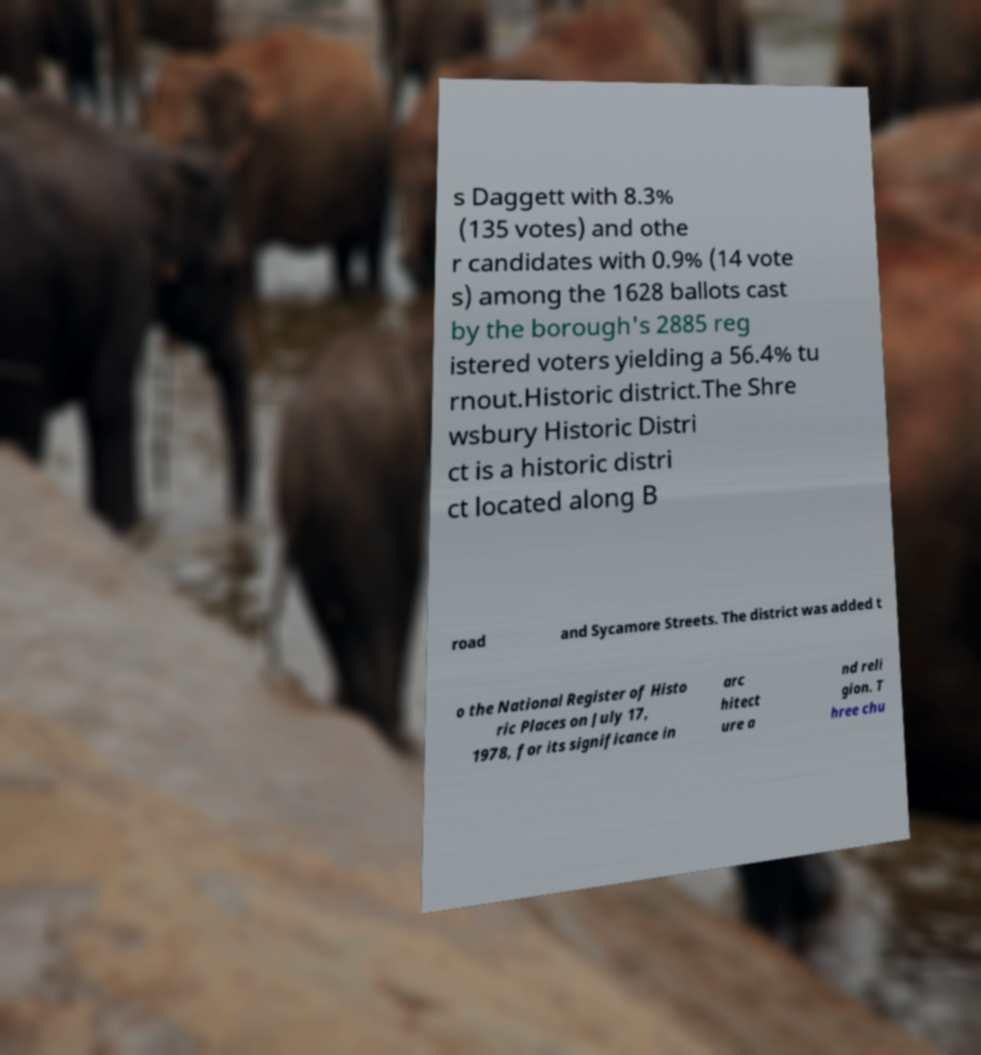Please read and relay the text visible in this image. What does it say? s Daggett with 8.3% (135 votes) and othe r candidates with 0.9% (14 vote s) among the 1628 ballots cast by the borough's 2885 reg istered voters yielding a 56.4% tu rnout.Historic district.The Shre wsbury Historic Distri ct is a historic distri ct located along B road and Sycamore Streets. The district was added t o the National Register of Histo ric Places on July 17, 1978, for its significance in arc hitect ure a nd reli gion. T hree chu 